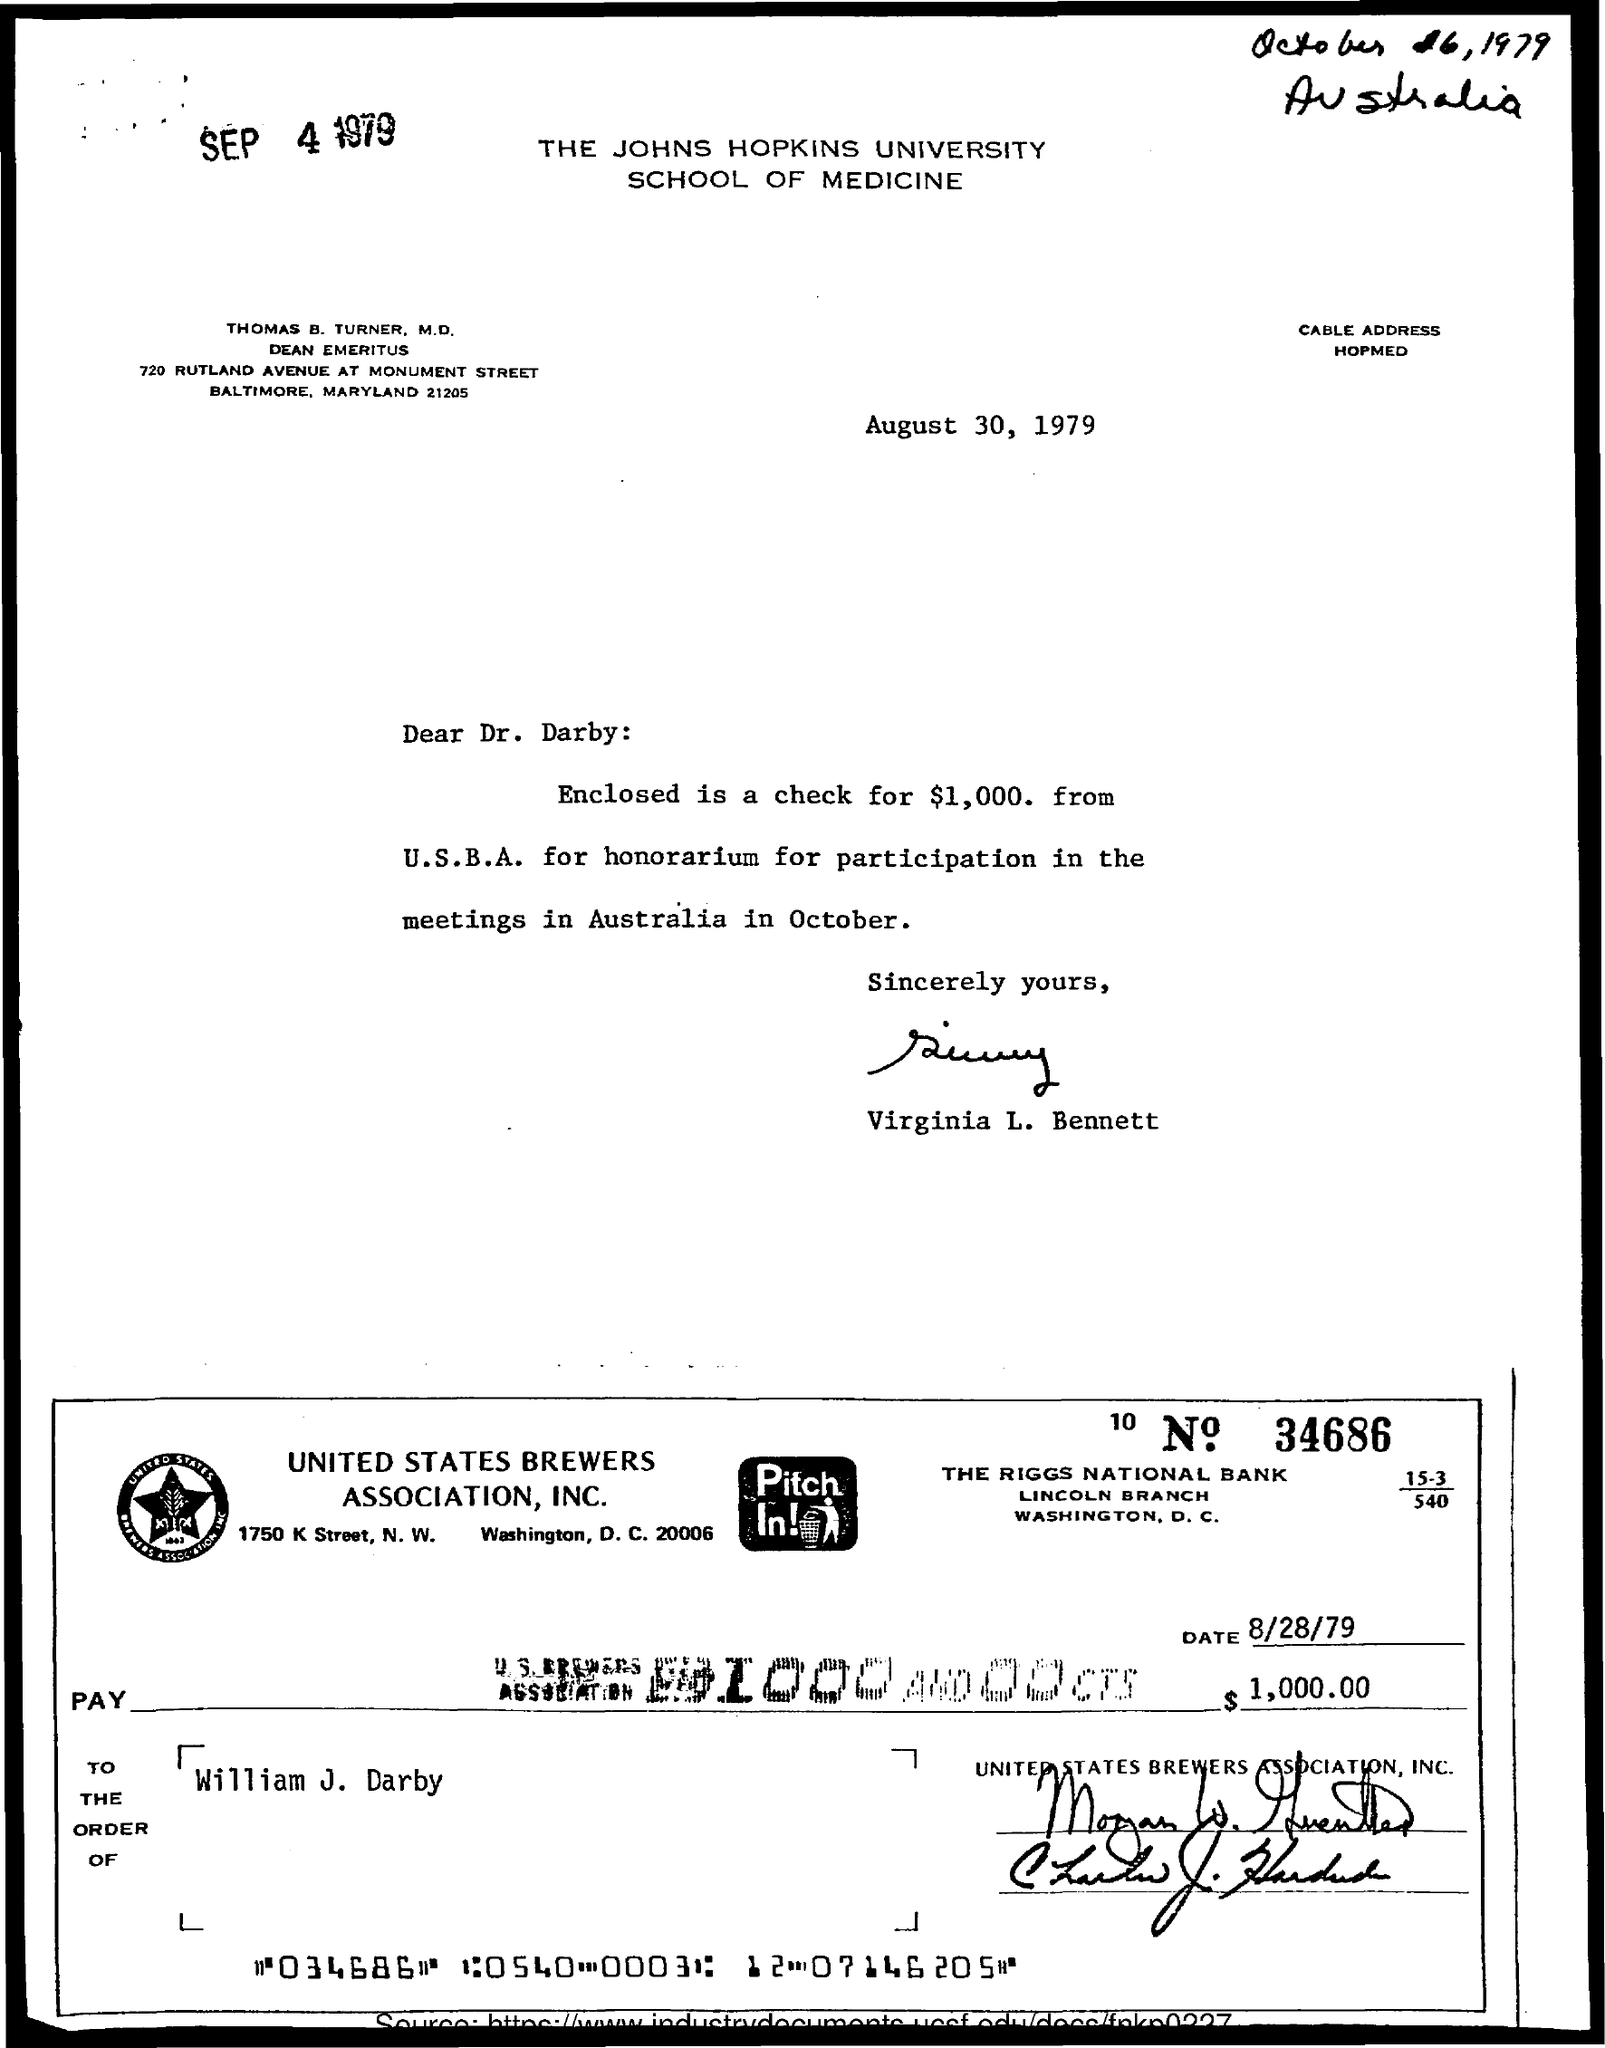What is written in the letter head ?
Give a very brief answer. THE JOHNS HOPKINS UNIVERSITY SCHOOL OF MEDICINE. Who is the Memorandum Addressed to ?
Offer a terse response. Dr. Darby. Who is the memorandum from ?
Keep it short and to the point. Virginia L. Bennett. 